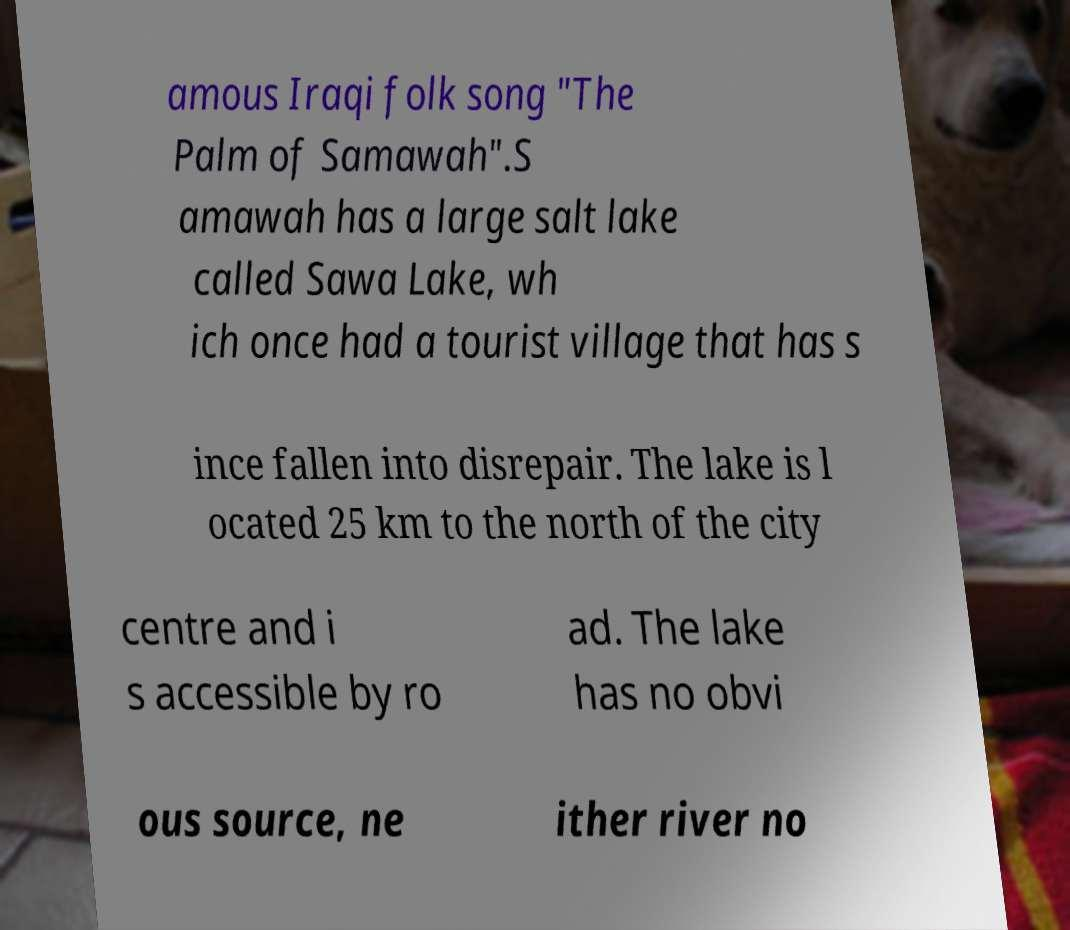For documentation purposes, I need the text within this image transcribed. Could you provide that? amous Iraqi folk song "The Palm of Samawah".S amawah has a large salt lake called Sawa Lake, wh ich once had a tourist village that has s ince fallen into disrepair. The lake is l ocated 25 km to the north of the city centre and i s accessible by ro ad. The lake has no obvi ous source, ne ither river no 